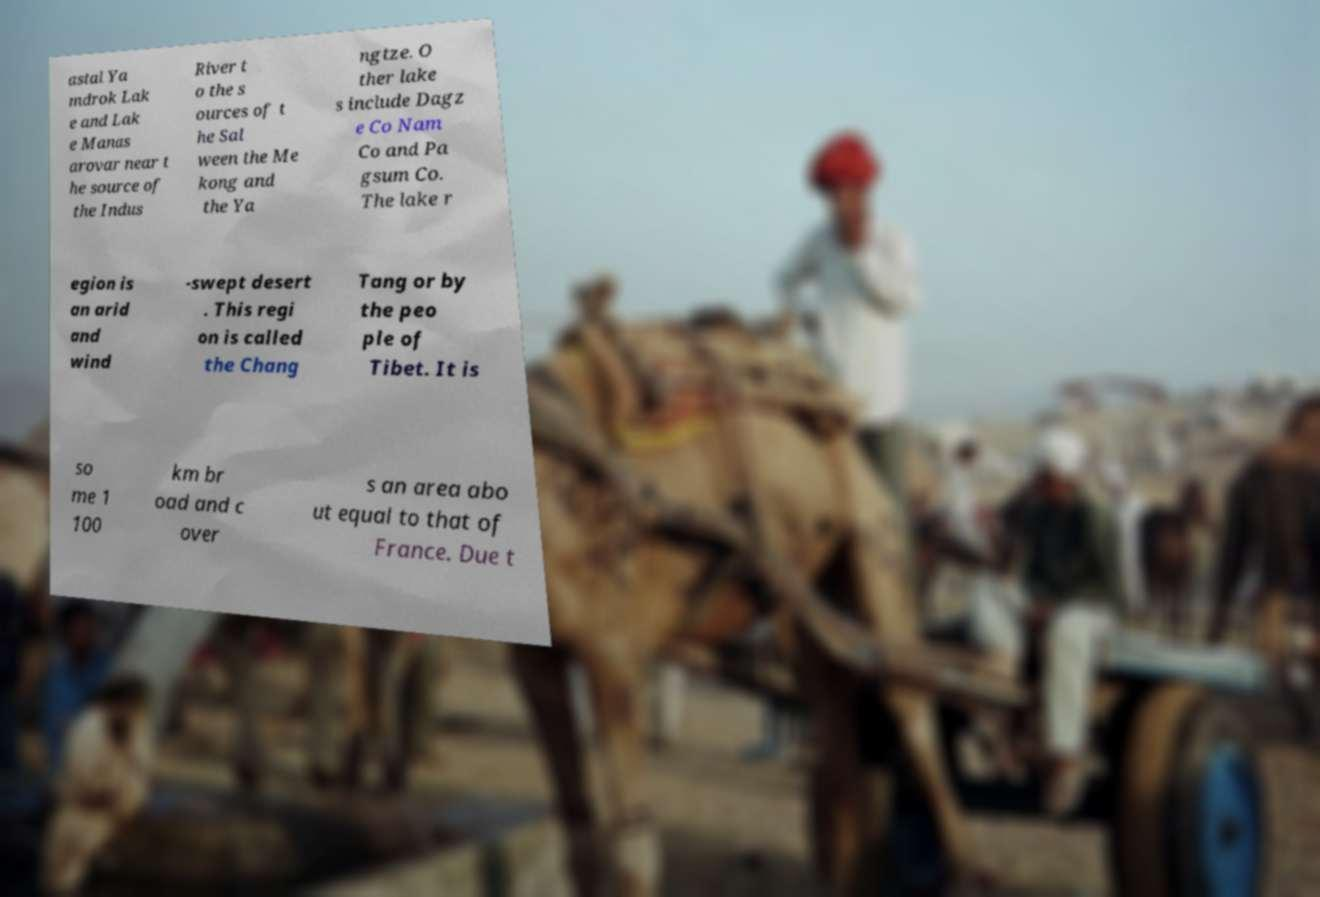Please read and relay the text visible in this image. What does it say? astal Ya mdrok Lak e and Lak e Manas arovar near t he source of the Indus River t o the s ources of t he Sal ween the Me kong and the Ya ngtze. O ther lake s include Dagz e Co Nam Co and Pa gsum Co. The lake r egion is an arid and wind -swept desert . This regi on is called the Chang Tang or by the peo ple of Tibet. It is so me 1 100 km br oad and c over s an area abo ut equal to that of France. Due t 